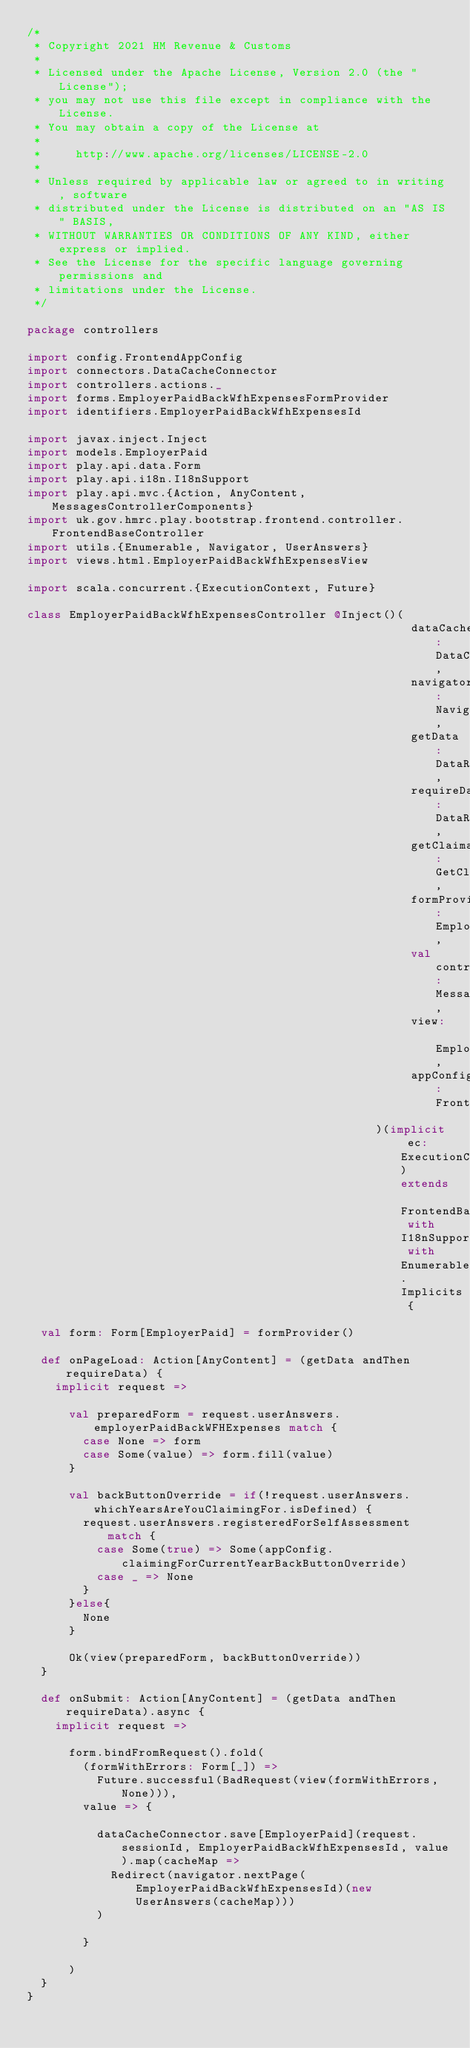Convert code to text. <code><loc_0><loc_0><loc_500><loc_500><_Scala_>/*
 * Copyright 2021 HM Revenue & Customs
 *
 * Licensed under the Apache License, Version 2.0 (the "License");
 * you may not use this file except in compliance with the License.
 * You may obtain a copy of the License at
 *
 *     http://www.apache.org/licenses/LICENSE-2.0
 *
 * Unless required by applicable law or agreed to in writing, software
 * distributed under the License is distributed on an "AS IS" BASIS,
 * WITHOUT WARRANTIES OR CONDITIONS OF ANY KIND, either express or implied.
 * See the License for the specific language governing permissions and
 * limitations under the License.
 */

package controllers

import config.FrontendAppConfig
import connectors.DataCacheConnector
import controllers.actions._
import forms.EmployerPaidBackWfhExpensesFormProvider
import identifiers.EmployerPaidBackWfhExpensesId

import javax.inject.Inject
import models.EmployerPaid
import play.api.data.Form
import play.api.i18n.I18nSupport
import play.api.mvc.{Action, AnyContent, MessagesControllerComponents}
import uk.gov.hmrc.play.bootstrap.frontend.controller.FrontendBaseController
import utils.{Enumerable, Navigator, UserAnswers}
import views.html.EmployerPaidBackWfhExpensesView

import scala.concurrent.{ExecutionContext, Future}

class EmployerPaidBackWfhExpensesController @Inject()(
                                                       dataCacheConnector: DataCacheConnector,
                                                       navigator: Navigator,
                                                       getData: DataRetrievalAction,
                                                       requireData: DataRequiredAction,
                                                       getClaimant: GetClaimantAction,
                                                       formProvider: EmployerPaidBackWfhExpensesFormProvider,
                                                       val controllerComponents: MessagesControllerComponents,
                                                       view: EmployerPaidBackWfhExpensesView,
                                                       appConfig: FrontendAppConfig
                                                  )(implicit ec: ExecutionContext) extends FrontendBaseController with I18nSupport with Enumerable.Implicits {

  val form: Form[EmployerPaid] = formProvider()

  def onPageLoad: Action[AnyContent] = (getData andThen requireData) {
    implicit request =>

      val preparedForm = request.userAnswers.employerPaidBackWFHExpenses match {
        case None => form
        case Some(value) => form.fill(value)
      }

      val backButtonOverride = if(!request.userAnswers.whichYearsAreYouClaimingFor.isDefined) {
        request.userAnswers.registeredForSelfAssessment match {
          case Some(true) => Some(appConfig.claimingForCurrentYearBackButtonOverride)
          case _ => None
        }
      }else{
        None
      }

      Ok(view(preparedForm, backButtonOverride))
  }

  def onSubmit: Action[AnyContent] = (getData andThen requireData).async {
    implicit request =>

      form.bindFromRequest().fold(
        (formWithErrors: Form[_]) =>
          Future.successful(BadRequest(view(formWithErrors, None))),
        value => {

          dataCacheConnector.save[EmployerPaid](request.sessionId, EmployerPaidBackWfhExpensesId, value).map(cacheMap =>
            Redirect(navigator.nextPage(EmployerPaidBackWfhExpensesId)(new UserAnswers(cacheMap)))
          )

        }

      )
  }
}
</code> 